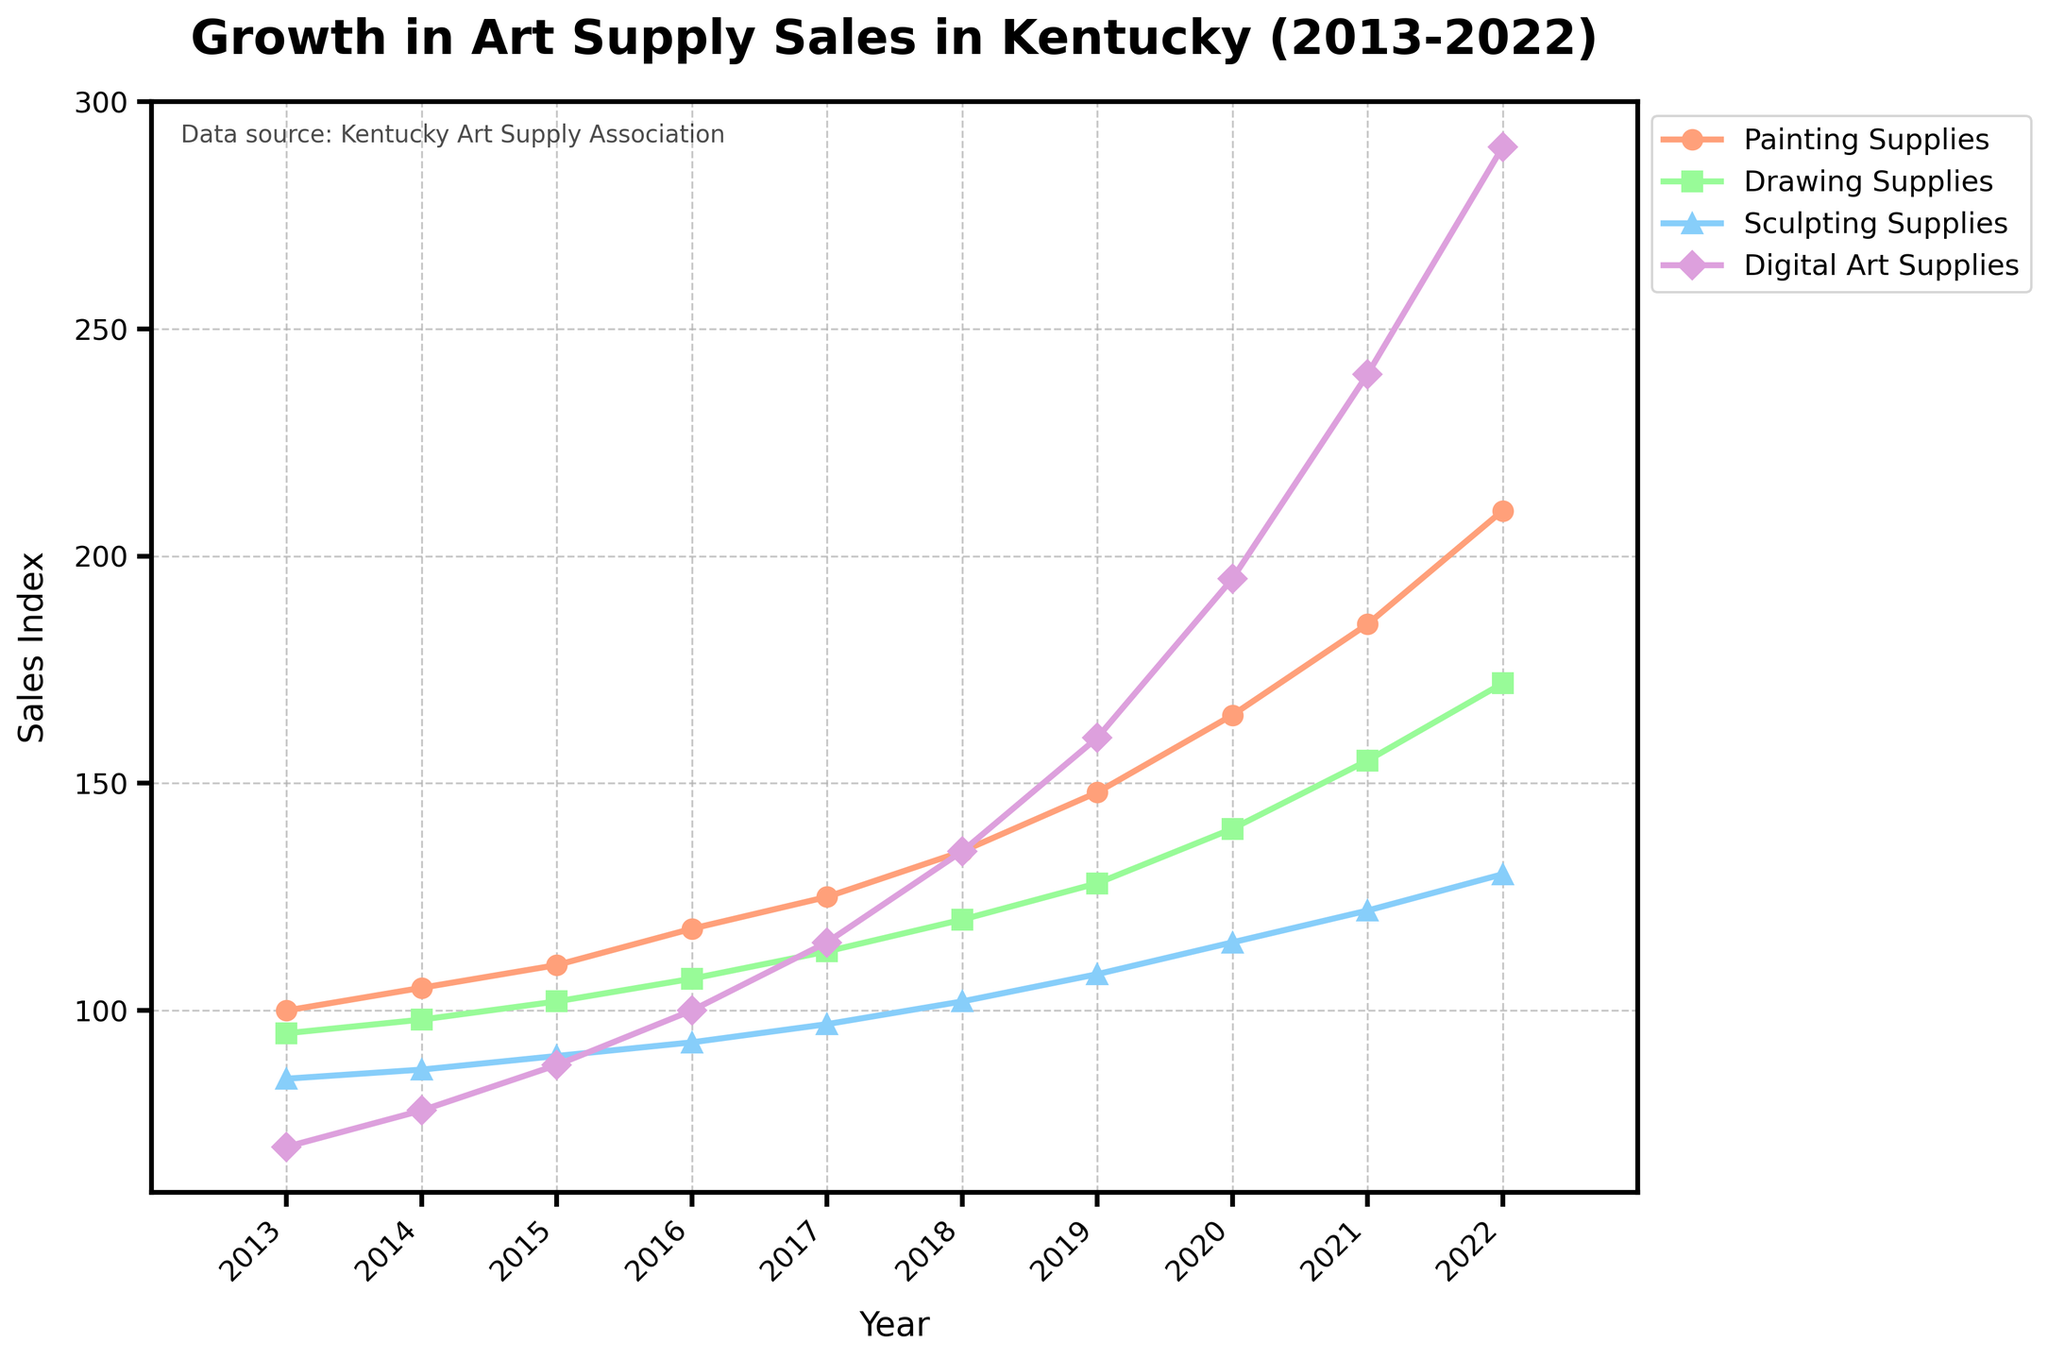How has the sales index for Digital Art Supplies changed from 2013 to 2022? Look at the data points for Digital Art Supplies in the given years. In 2013, the sales index is 70, and in 2022, it is 290.
Answer: It increased by 220 Which art supply saw the greatest growth in sales index over the entire decade? Calculate the difference in sales index from 2013 to 2022 for each category:
- Painting Supplies: 210 - 100 = 110
- Drawing Supplies: 172 - 95 = 77
- Sculpting Supplies: 130 - 85 = 45
- Digital Art Supplies: 290 - 70 = 220
Digital Art Supplies had the greatest growth.
Answer: Digital Art Supplies Comparing the sales index of Painting Supplies and Drawing Supplies in 2018, which one was higher and by how much? Look at the values for 2018: Painting Supplies = 135, Drawing Supplies = 120. The difference is 135 - 120 = 15.
Answer: Painting Supplies is higher by 15 What was the average sales index of Sculpting Supplies over the years 2013 to 2015? Add the sales indexes for those years and divide by the number of years: (85 + 87 + 90) / 3 = 262 / 3 = 87.33
Answer: 87.33 What is the visual color representation of Drawing Supplies' sales line in the chart? Observe the chart and note that Drawing Supplies are represented by a green line.
Answer: green Which year shows the largest single-year increase in sales index for Digital Art Supplies and what is the increase? Look at the values year by year and find the largest difference:
- 2014: 78 - 70 = 8
- 2015: 88 - 78 = 10
- 2016: 100 - 88 = 12
- 2017: 115 - 100 = 15
- 2018: 135 - 115 = 20
- 2019: 160 - 135 = 25
- 2020: 195 - 160 = 35
- 2021: 240 - 195 = 45
- 2022: 290 - 240 = 50
The largest increase is in 2022 with an increase of 50.
Answer: 2022 with an increase of 50 From 2015 to 2020, which medium had the most consistent growth in sales index? Calculate the difference between consecutive years' values and see which one has the smallest variation:
- Painting Supplies: 8, 7, 10, 13, 17
- Drawing Supplies: 6, 7, 7, 8, 12
- Sculpting Supplies: 3, 4, 5, 6, 7
- Digital Art Supplies: 10, 12, 15, 20, 35
Sculpting Supplies has the smallest and most consistent differences.
Answer: Sculpting Supplies In 2022, how does the sales index of Painting Supplies compare to the sum of the sales indexes of Drawing Supplies and Sculpting Supplies? Sum the sales indexes of Drawing Supplies and Sculpting Supplies in 2022: 172 + 130 = 302. Compare to Painting Supplies: 210 < 302.
Answer: Less than Across all these years, which supplies show a trend of exponential growth? Look at the growth patterns in the chart, and Digital Art Supplies show an exponential increase in their sales index.
Answer: Digital Art Supplies What is the percentage increase in the sales index for Drawing Supplies from 2013 to 2022? Calculate the initial and final index, then use the formula (final - initial) / initial * 100: (172 - 95) / 95 * 100 = 81.05%.
Answer: 81.05% 